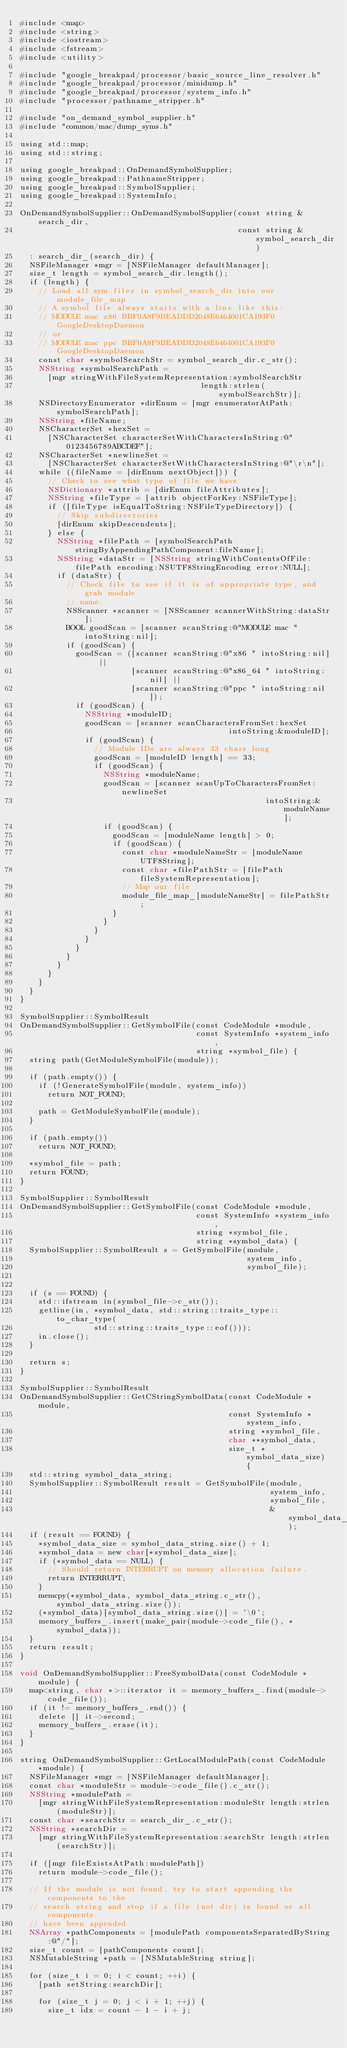Convert code to text. <code><loc_0><loc_0><loc_500><loc_500><_ObjectiveC_>#include <map>
#include <string>
#include <iostream>
#include <fstream>
#include <utility>

#include "google_breakpad/processor/basic_source_line_resolver.h"
#include "google_breakpad/processor/minidump.h"
#include "google_breakpad/processor/system_info.h"
#include "processor/pathname_stripper.h"

#include "on_demand_symbol_supplier.h"
#include "common/mac/dump_syms.h"

using std::map;
using std::string;

using google_breakpad::OnDemandSymbolSupplier;
using google_breakpad::PathnameStripper;
using google_breakpad::SymbolSupplier;
using google_breakpad::SystemInfo;

OnDemandSymbolSupplier::OnDemandSymbolSupplier(const string &search_dir,
                                               const string &symbol_search_dir)
  : search_dir_(search_dir) {
  NSFileManager *mgr = [NSFileManager defaultManager];
  size_t length = symbol_search_dir.length();
  if (length) {
    // Load all sym files in symbol_search_dir into our module_file_map
    // A symbol file always starts with a line like this:
    // MODULE mac x86 BBF0A8F9BEADDD2048E6464001CA193F0 GoogleDesktopDaemon
    // or
    // MODULE mac ppc BBF0A8F9BEADDD2048E6464001CA193F0 GoogleDesktopDaemon
    const char *symbolSearchStr = symbol_search_dir.c_str();
    NSString *symbolSearchPath = 
      [mgr stringWithFileSystemRepresentation:symbolSearchStr 
                                       length:strlen(symbolSearchStr)];
    NSDirectoryEnumerator *dirEnum = [mgr enumeratorAtPath:symbolSearchPath];
    NSString *fileName;
    NSCharacterSet *hexSet = 
      [NSCharacterSet characterSetWithCharactersInString:@"0123456789ABCDEF"];
    NSCharacterSet *newlineSet = 
      [NSCharacterSet characterSetWithCharactersInString:@"\r\n"];
    while ((fileName = [dirEnum nextObject])) {
      // Check to see what type of file we have
      NSDictionary *attrib = [dirEnum fileAttributes];
      NSString *fileType = [attrib objectForKey:NSFileType];
      if ([fileType isEqualToString:NSFileTypeDirectory]) {
        // Skip subdirectories
        [dirEnum skipDescendents];
      } else {
        NSString *filePath = [symbolSearchPath stringByAppendingPathComponent:fileName];
        NSString *dataStr = [NSString stringWithContentsOfFile:filePath encoding:NSUTF8StringEncoding error:NULL];
        if (dataStr) {
          // Check file to see if it is of appropriate type, and grab module
          // name.
          NSScanner *scanner = [NSScanner scannerWithString:dataStr];
          BOOL goodScan = [scanner scanString:@"MODULE mac " intoString:nil];
          if (goodScan) {
            goodScan = ([scanner scanString:@"x86 " intoString:nil] ||
                        [scanner scanString:@"x86_64 " intoString:nil] ||
                        [scanner scanString:@"ppc " intoString:nil]);
            if (goodScan) {
              NSString *moduleID;
              goodScan = [scanner scanCharactersFromSet:hexSet 
                                             intoString:&moduleID];
              if (goodScan) {
                // Module IDs are always 33 chars long
                goodScan = [moduleID length] == 33;
                if (goodScan) {
                  NSString *moduleName;
                  goodScan = [scanner scanUpToCharactersFromSet:newlineSet 
                                                     intoString:&moduleName];
                  if (goodScan) {
                    goodScan = [moduleName length] > 0;
                    if (goodScan) {
                      const char *moduleNameStr = [moduleName UTF8String];
                      const char *filePathStr = [filePath fileSystemRepresentation];
                      // Map our file
                      module_file_map_[moduleNameStr] = filePathStr;
                    }
                  }
                }
              }
            }
          }
        }
      }
    }
  }
}

SymbolSupplier::SymbolResult
OnDemandSymbolSupplier::GetSymbolFile(const CodeModule *module,
                                      const SystemInfo *system_info,
                                      string *symbol_file) {
  string path(GetModuleSymbolFile(module));

  if (path.empty()) {
    if (!GenerateSymbolFile(module, system_info))
      return NOT_FOUND;

    path = GetModuleSymbolFile(module);
  }

  if (path.empty())
    return NOT_FOUND;

  *symbol_file = path;
  return FOUND;
}

SymbolSupplier::SymbolResult
OnDemandSymbolSupplier::GetSymbolFile(const CodeModule *module,
                                      const SystemInfo *system_info,
                                      string *symbol_file,
                                      string *symbol_data) {
  SymbolSupplier::SymbolResult s = GetSymbolFile(module,
                                                 system_info,
                                                 symbol_file);


  if (s == FOUND) {
    std::ifstream in(symbol_file->c_str());
    getline(in, *symbol_data, std::string::traits_type::to_char_type(
                std::string::traits_type::eof()));
    in.close();
  }

  return s;
}

SymbolSupplier::SymbolResult
OnDemandSymbolSupplier::GetCStringSymbolData(const CodeModule *module,
                                             const SystemInfo *system_info,
                                             string *symbol_file,
                                             char **symbol_data,
                                             size_t *symbol_data_size) {
  std::string symbol_data_string;
  SymbolSupplier::SymbolResult result = GetSymbolFile(module,
                                                      system_info,
                                                      symbol_file,
                                                      &symbol_data_string);
  if (result == FOUND) {
    *symbol_data_size = symbol_data_string.size() + 1;
    *symbol_data = new char[*symbol_data_size];
    if (*symbol_data == NULL) {
      // Should return INTERRUPT on memory allocation failure.
      return INTERRUPT;
    }
    memcpy(*symbol_data, symbol_data_string.c_str(), symbol_data_string.size());
    (*symbol_data)[symbol_data_string.size()] = '\0';
    memory_buffers_.insert(make_pair(module->code_file(), *symbol_data));
  }
  return result;
}

void OnDemandSymbolSupplier::FreeSymbolData(const CodeModule *module) {
  map<string, char *>::iterator it = memory_buffers_.find(module->code_file());
  if (it != memory_buffers_.end()) {
    delete [] it->second;
    memory_buffers_.erase(it);
  }
}

string OnDemandSymbolSupplier::GetLocalModulePath(const CodeModule *module) {
  NSFileManager *mgr = [NSFileManager defaultManager];
  const char *moduleStr = module->code_file().c_str();
  NSString *modulePath =
    [mgr stringWithFileSystemRepresentation:moduleStr length:strlen(moduleStr)];
  const char *searchStr = search_dir_.c_str();
  NSString *searchDir =
    [mgr stringWithFileSystemRepresentation:searchStr length:strlen(searchStr)];

  if ([mgr fileExistsAtPath:modulePath])
    return module->code_file();

  // If the module is not found, try to start appending the components to the
  // search string and stop if a file (not dir) is found or all components
  // have been appended
  NSArray *pathComponents = [modulePath componentsSeparatedByString:@"/"];
  size_t count = [pathComponents count];
  NSMutableString *path = [NSMutableString string];

  for (size_t i = 0; i < count; ++i) {
    [path setString:searchDir];

    for (size_t j = 0; j < i + 1; ++j) {
      size_t idx = count - 1 - i + j;</code> 